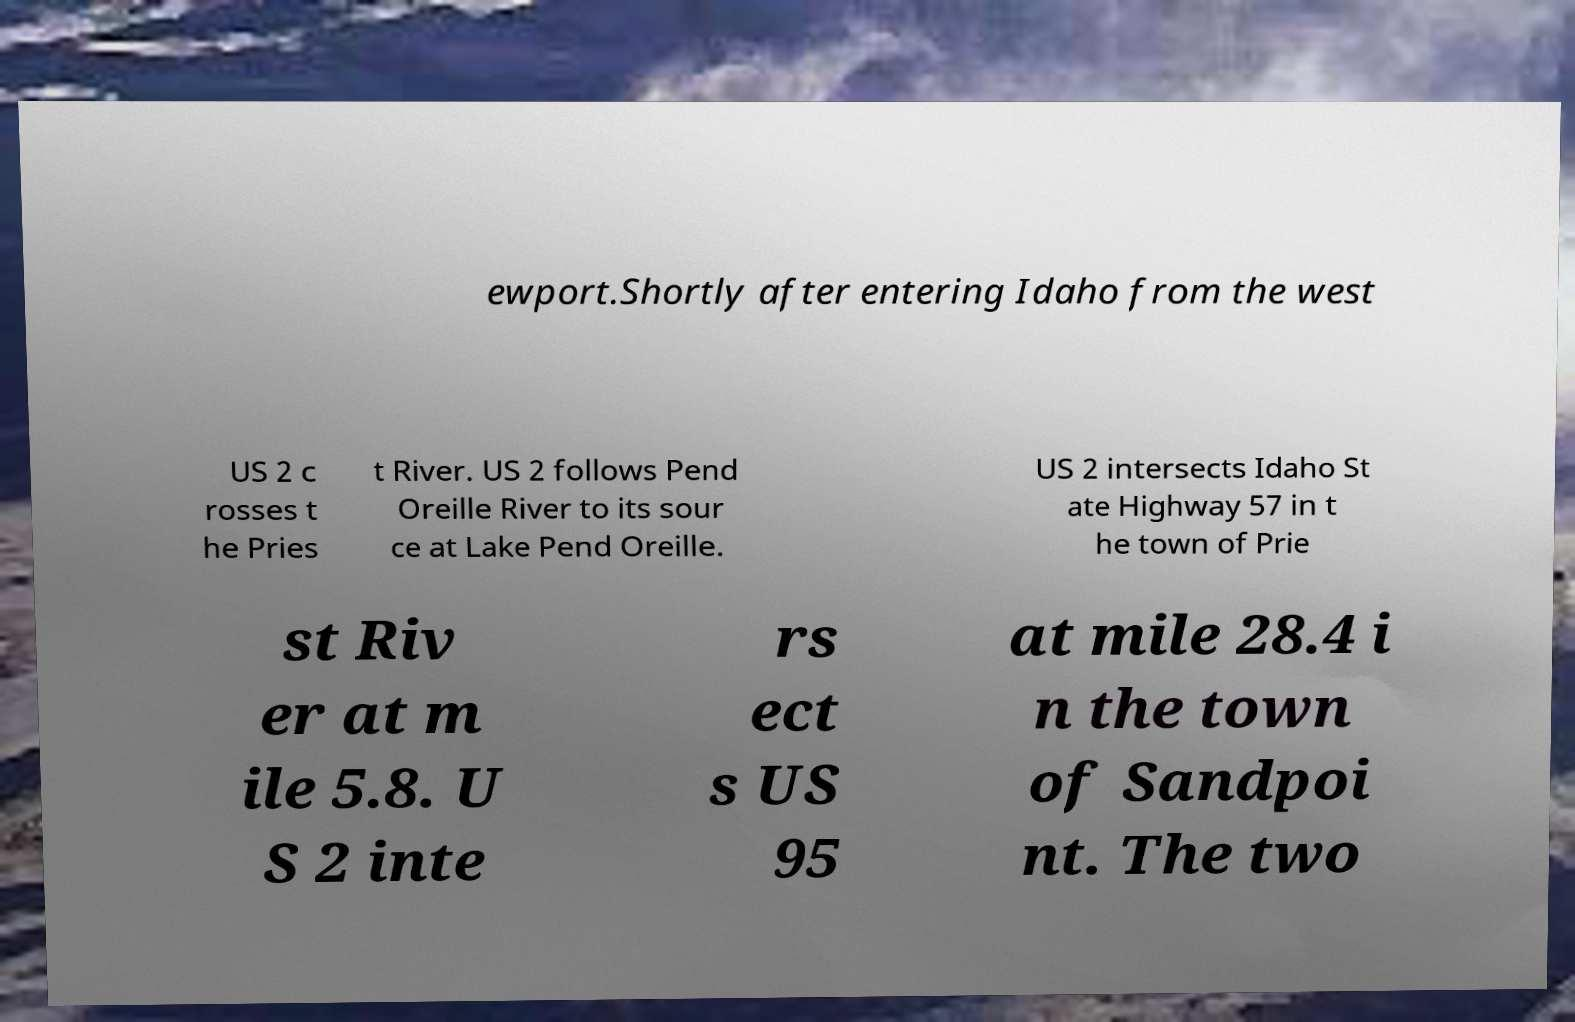There's text embedded in this image that I need extracted. Can you transcribe it verbatim? ewport.Shortly after entering Idaho from the west US 2 c rosses t he Pries t River. US 2 follows Pend Oreille River to its sour ce at Lake Pend Oreille. US 2 intersects Idaho St ate Highway 57 in t he town of Prie st Riv er at m ile 5.8. U S 2 inte rs ect s US 95 at mile 28.4 i n the town of Sandpoi nt. The two 